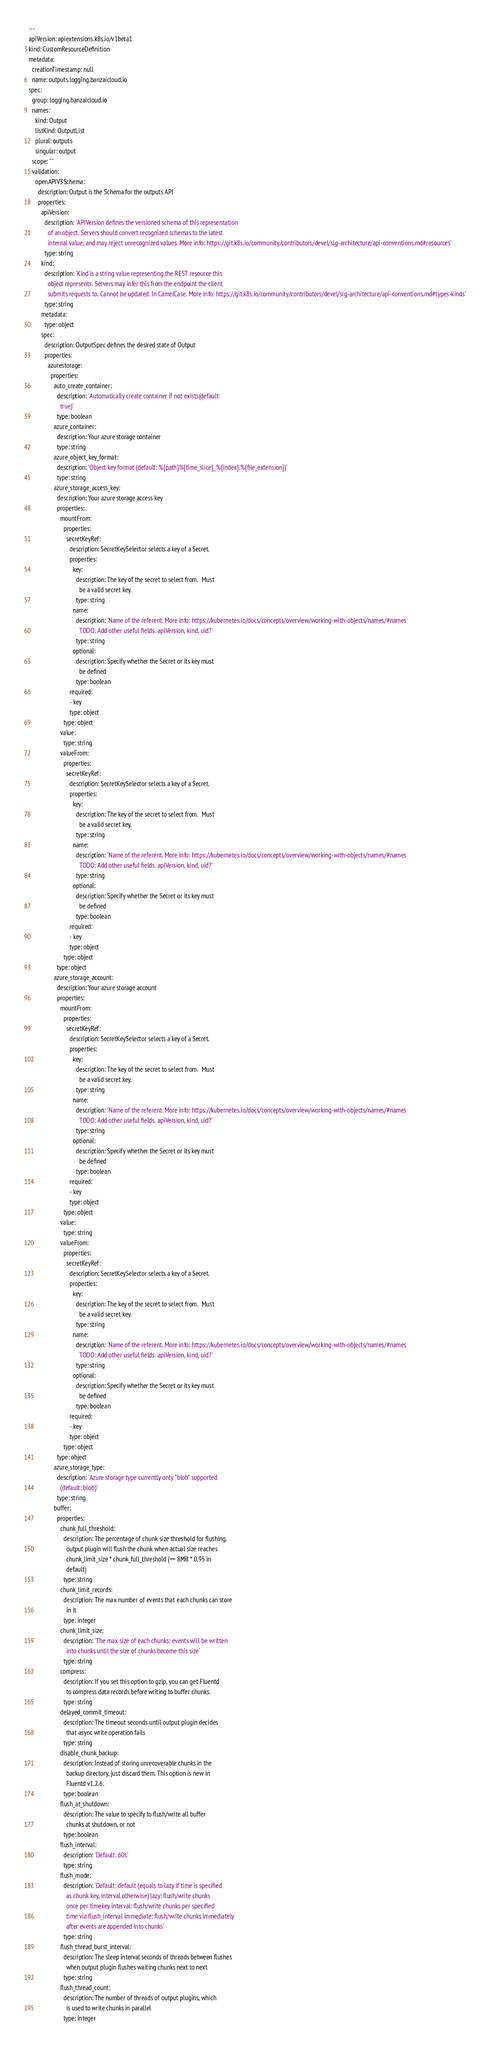Convert code to text. <code><loc_0><loc_0><loc_500><loc_500><_YAML_>
---
apiVersion: apiextensions.k8s.io/v1beta1
kind: CustomResourceDefinition
metadata:
  creationTimestamp: null
  name: outputs.logging.banzaicloud.io
spec:
  group: logging.banzaicloud.io
  names:
    kind: Output
    listKind: OutputList
    plural: outputs
    singular: output
  scope: ""
  validation:
    openAPIV3Schema:
      description: Output is the Schema for the outputs API
      properties:
        apiVersion:
          description: 'APIVersion defines the versioned schema of this representation
            of an object. Servers should convert recognized schemas to the latest
            internal value, and may reject unrecognized values. More info: https://git.k8s.io/community/contributors/devel/sig-architecture/api-conventions.md#resources'
          type: string
        kind:
          description: 'Kind is a string value representing the REST resource this
            object represents. Servers may infer this from the endpoint the client
            submits requests to. Cannot be updated. In CamelCase. More info: https://git.k8s.io/community/contributors/devel/sig-architecture/api-conventions.md#types-kinds'
          type: string
        metadata:
          type: object
        spec:
          description: OutputSpec defines the desired state of Output
          properties:
            azurestorage:
              properties:
                auto_create_container:
                  description: 'Automatically create container if not exists(default:
                    true)'
                  type: boolean
                azure_container:
                  description: Your azure storage container
                  type: string
                azure_object_key_format:
                  description: 'Object key format (default: %{path}%{time_slice}_%{index}.%{file_extension})'
                  type: string
                azure_storage_access_key:
                  description: Your azure storage access key
                  properties:
                    mountFrom:
                      properties:
                        secretKeyRef:
                          description: SecretKeySelector selects a key of a Secret.
                          properties:
                            key:
                              description: The key of the secret to select from.  Must
                                be a valid secret key.
                              type: string
                            name:
                              description: 'Name of the referent. More info: https://kubernetes.io/docs/concepts/overview/working-with-objects/names/#names
                                TODO: Add other useful fields. apiVersion, kind, uid?'
                              type: string
                            optional:
                              description: Specify whether the Secret or its key must
                                be defined
                              type: boolean
                          required:
                          - key
                          type: object
                      type: object
                    value:
                      type: string
                    valueFrom:
                      properties:
                        secretKeyRef:
                          description: SecretKeySelector selects a key of a Secret.
                          properties:
                            key:
                              description: The key of the secret to select from.  Must
                                be a valid secret key.
                              type: string
                            name:
                              description: 'Name of the referent. More info: https://kubernetes.io/docs/concepts/overview/working-with-objects/names/#names
                                TODO: Add other useful fields. apiVersion, kind, uid?'
                              type: string
                            optional:
                              description: Specify whether the Secret or its key must
                                be defined
                              type: boolean
                          required:
                          - key
                          type: object
                      type: object
                  type: object
                azure_storage_account:
                  description: Your azure storage account
                  properties:
                    mountFrom:
                      properties:
                        secretKeyRef:
                          description: SecretKeySelector selects a key of a Secret.
                          properties:
                            key:
                              description: The key of the secret to select from.  Must
                                be a valid secret key.
                              type: string
                            name:
                              description: 'Name of the referent. More info: https://kubernetes.io/docs/concepts/overview/working-with-objects/names/#names
                                TODO: Add other useful fields. apiVersion, kind, uid?'
                              type: string
                            optional:
                              description: Specify whether the Secret or its key must
                                be defined
                              type: boolean
                          required:
                          - key
                          type: object
                      type: object
                    value:
                      type: string
                    valueFrom:
                      properties:
                        secretKeyRef:
                          description: SecretKeySelector selects a key of a Secret.
                          properties:
                            key:
                              description: The key of the secret to select from.  Must
                                be a valid secret key.
                              type: string
                            name:
                              description: 'Name of the referent. More info: https://kubernetes.io/docs/concepts/overview/working-with-objects/names/#names
                                TODO: Add other useful fields. apiVersion, kind, uid?'
                              type: string
                            optional:
                              description: Specify whether the Secret or its key must
                                be defined
                              type: boolean
                          required:
                          - key
                          type: object
                      type: object
                  type: object
                azure_storage_type:
                  description: 'Azure storage type currently only "blob" supported
                    (default: blob)'
                  type: string
                buffer:
                  properties:
                    chunk_full_threshold:
                      description: The percentage of chunk size threshold for flushing.
                        output plugin will flush the chunk when actual size reaches
                        chunk_limit_size * chunk_full_threshold (== 8MB * 0.95 in
                        default)
                      type: string
                    chunk_limit_records:
                      description: The max number of events that each chunks can store
                        in it
                      type: integer
                    chunk_limit_size:
                      description: 'The max size of each chunks: events will be written
                        into chunks until the size of chunks become this size'
                      type: string
                    compress:
                      description: If you set this option to gzip, you can get Fluentd
                        to compress data records before writing to buffer chunks.
                      type: string
                    delayed_commit_timeout:
                      description: The timeout seconds until output plugin decides
                        that async write operation fails
                      type: string
                    disable_chunk_backup:
                      description: Instead of storing unrecoverable chunks in the
                        backup directory, just discard them. This option is new in
                        Fluentd v1.2.6.
                      type: boolean
                    flush_at_shutdown:
                      description: The value to specify to flush/write all buffer
                        chunks at shutdown, or not
                      type: boolean
                    flush_interval:
                      description: 'Default: 60s'
                      type: string
                    flush_mode:
                      description: 'Default: default (equals to lazy if time is specified
                        as chunk key, interval otherwise) lazy: flush/write chunks
                        once per timekey interval: flush/write chunks per specified
                        time via flush_interval immediate: flush/write chunks immediately
                        after events are appended into chunks'
                      type: string
                    flush_thread_burst_interval:
                      description: The sleep interval seconds of threads between flushes
                        when output plugin flushes waiting chunks next to next
                      type: string
                    flush_thread_count:
                      description: The number of threads of output plugins, which
                        is used to write chunks in parallel
                      type: integer</code> 